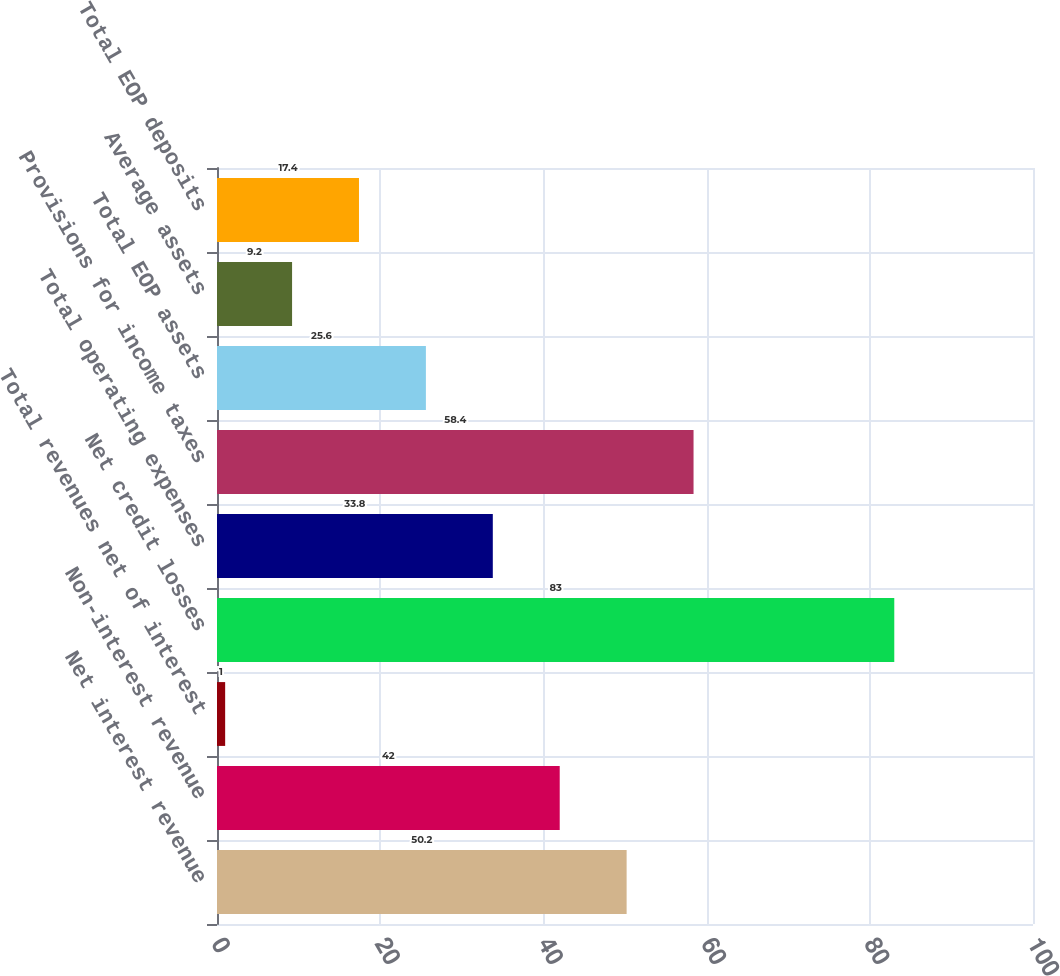Convert chart to OTSL. <chart><loc_0><loc_0><loc_500><loc_500><bar_chart><fcel>Net interest revenue<fcel>Non-interest revenue<fcel>Total revenues net of interest<fcel>Net credit losses<fcel>Total operating expenses<fcel>Provisions for income taxes<fcel>Total EOP assets<fcel>Average assets<fcel>Total EOP deposits<nl><fcel>50.2<fcel>42<fcel>1<fcel>83<fcel>33.8<fcel>58.4<fcel>25.6<fcel>9.2<fcel>17.4<nl></chart> 